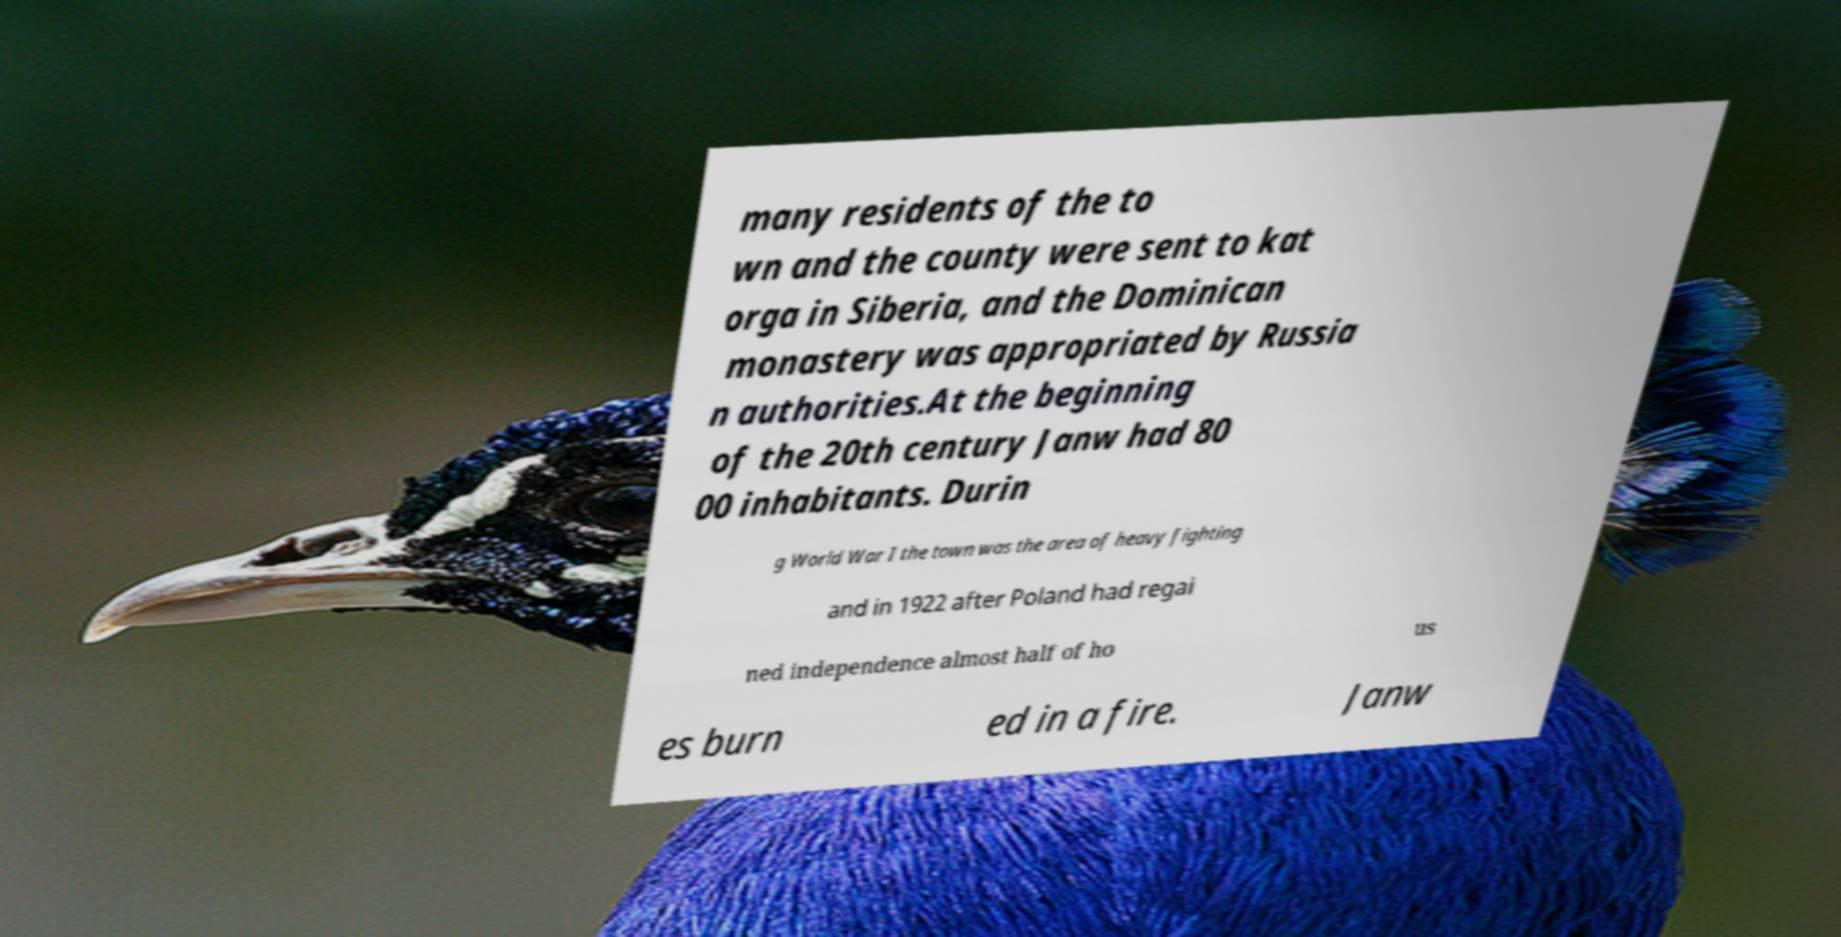Please identify and transcribe the text found in this image. many residents of the to wn and the county were sent to kat orga in Siberia, and the Dominican monastery was appropriated by Russia n authorities.At the beginning of the 20th century Janw had 80 00 inhabitants. Durin g World War I the town was the area of heavy fighting and in 1922 after Poland had regai ned independence almost half of ho us es burn ed in a fire. Janw 